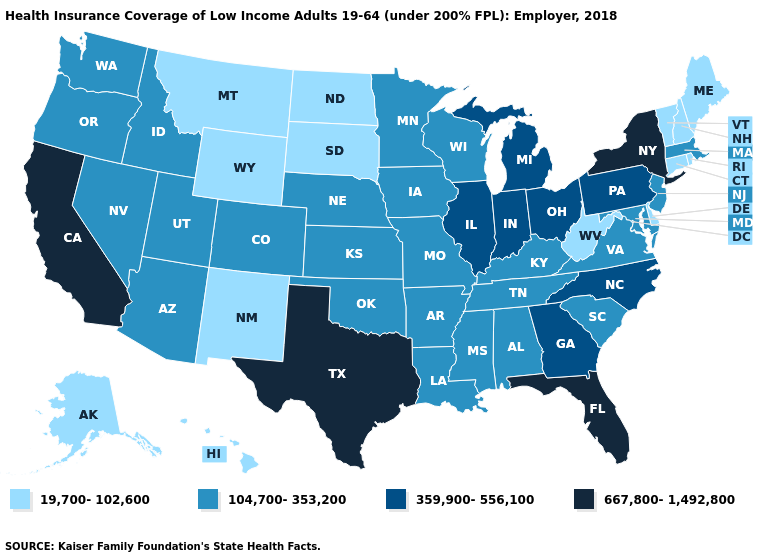Which states have the highest value in the USA?
Give a very brief answer. California, Florida, New York, Texas. Which states hav the highest value in the West?
Answer briefly. California. What is the highest value in the Northeast ?
Concise answer only. 667,800-1,492,800. Name the states that have a value in the range 359,900-556,100?
Give a very brief answer. Georgia, Illinois, Indiana, Michigan, North Carolina, Ohio, Pennsylvania. What is the value of North Carolina?
Be succinct. 359,900-556,100. What is the lowest value in the South?
Quick response, please. 19,700-102,600. Which states have the highest value in the USA?
Write a very short answer. California, Florida, New York, Texas. Name the states that have a value in the range 667,800-1,492,800?
Quick response, please. California, Florida, New York, Texas. Among the states that border Illinois , does Missouri have the lowest value?
Short answer required. Yes. Is the legend a continuous bar?
Keep it brief. No. Name the states that have a value in the range 19,700-102,600?
Answer briefly. Alaska, Connecticut, Delaware, Hawaii, Maine, Montana, New Hampshire, New Mexico, North Dakota, Rhode Island, South Dakota, Vermont, West Virginia, Wyoming. Does Colorado have the lowest value in the USA?
Be succinct. No. Among the states that border Nevada , which have the highest value?
Write a very short answer. California. Is the legend a continuous bar?
Answer briefly. No. Which states hav the highest value in the West?
Be succinct. California. 